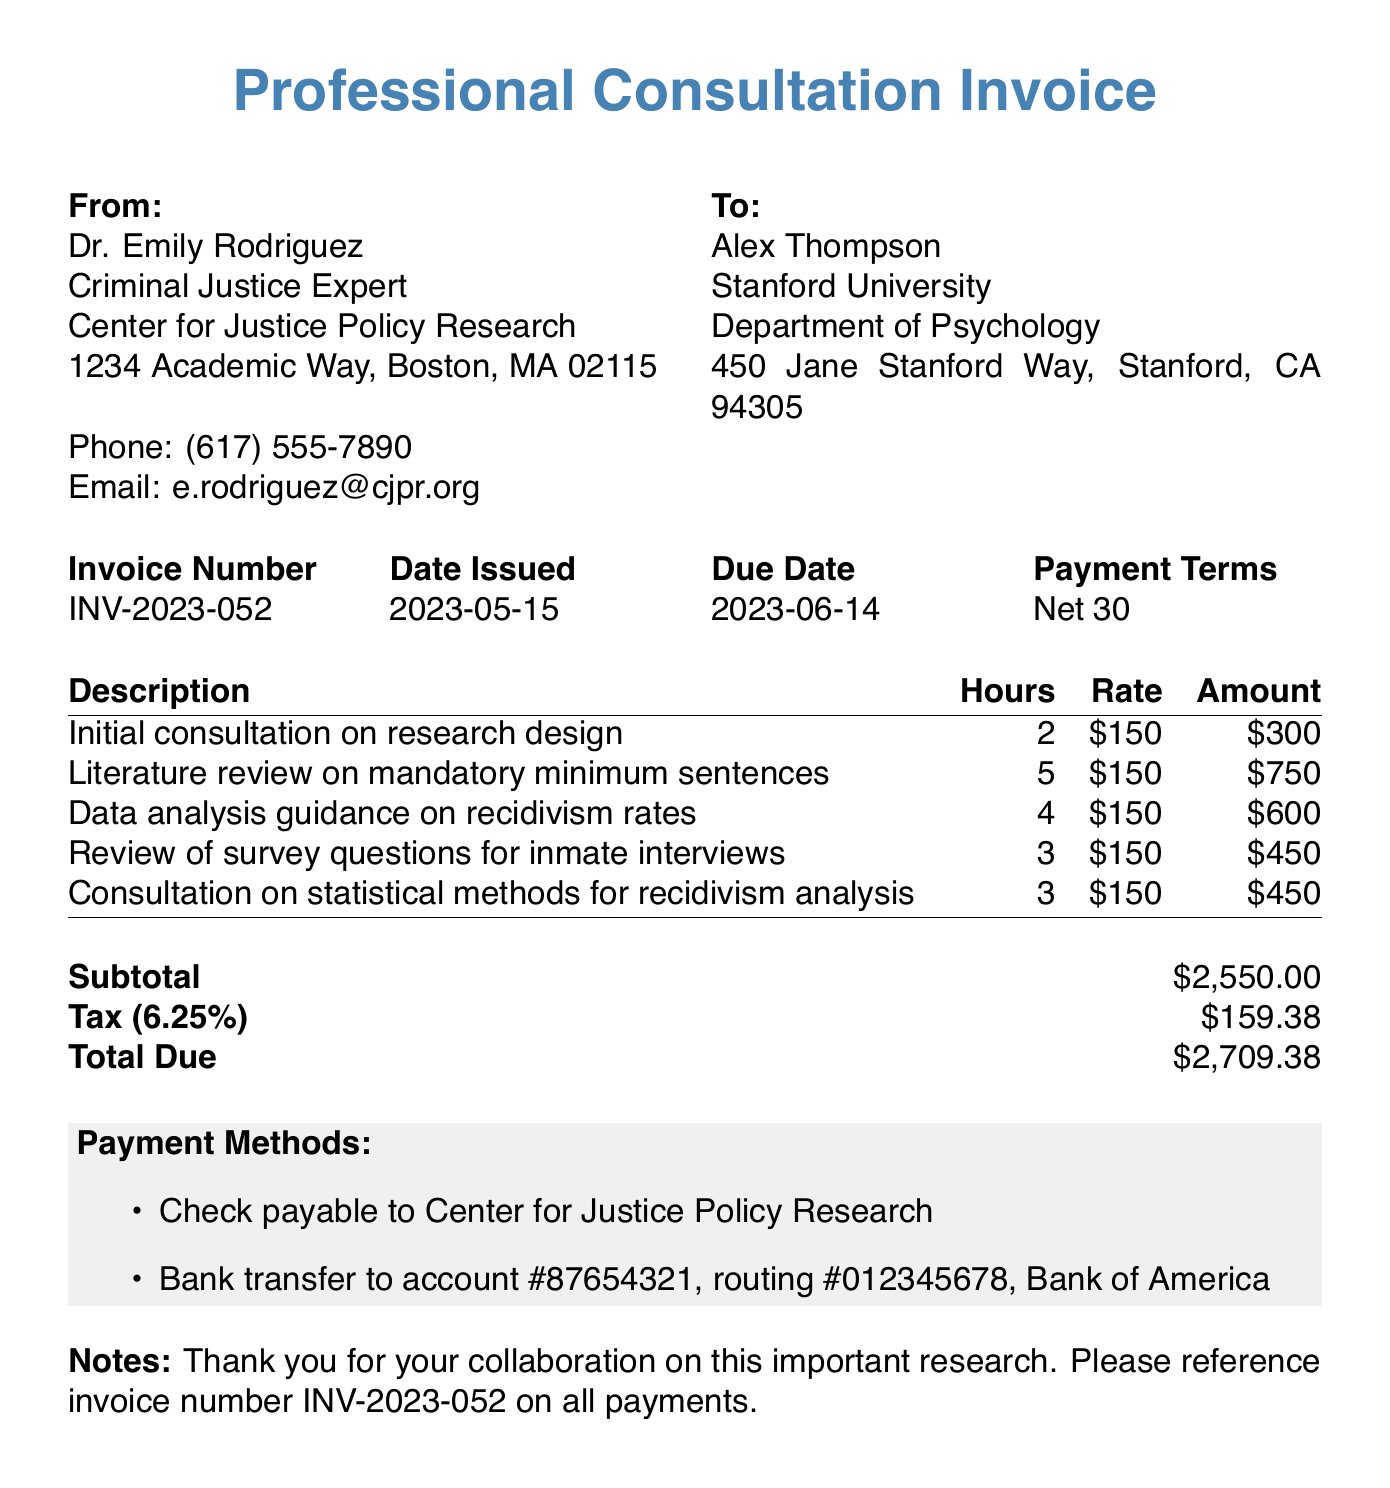What is the invoice number? The invoice number is a unique identifier for this invoice, found in the document.
Answer: INV-2023-052 Who issued the consultation invoice? The invoice is issued by the criminal justice expert mentioned in the document.
Answer: Dr. Emily Rodriguez What is the total due amount? The total due is the final amount that the client needs to pay as stated in the invoice.
Answer: 2709.38 How many hours were spent on the literature review? The hours spent on the literature review are detailed in the services provided section of the document.
Answer: 5 What is the tax rate applied in this invoice? The tax rate is given as a percentage in the invoice and is used to calculate the tax amount.
Answer: 6.25% What service required the most hours? This question combines information to determine which service had the highest time expenditure.
Answer: Literature review on mandatory minimum sentences When is the payment due date? The due date informs the client when the payment must be completed to avoid late fees.
Answer: 2023-06-14 What type of payment methods are accepted? The payment methods are listed in the invoice, specifying how the payment can be made.
Answer: Check, Bank transfer What is noted in the invoice? The notes section often contains additional information or gratitude from the consultant to the client.
Answer: Thank you for your collaboration on this important research 